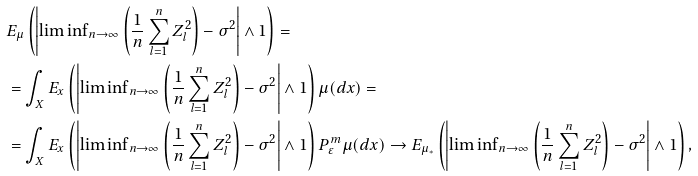Convert formula to latex. <formula><loc_0><loc_0><loc_500><loc_500>& E _ { \mu } \left ( \left | { \lim \inf } _ { n \to \infty } \left ( \frac { 1 } { n } \sum _ { l = 1 } ^ { n } Z _ { l } ^ { 2 } \right ) - \sigma ^ { 2 } \right | \wedge 1 \right ) = \\ & = \int _ { X } E _ { x } \left ( \left | { \lim \inf } _ { n \to \infty } \left ( \frac { 1 } { n } \sum _ { l = 1 } ^ { n } Z _ { l } ^ { 2 } \right ) - \sigma ^ { 2 } \right | \wedge 1 \right ) \mu ( d x ) = \\ & = \int _ { X } E _ { x } \left ( \left | { \lim \inf } _ { n \to \infty } \left ( \frac { 1 } { n } \sum _ { l = 1 } ^ { n } Z _ { l } ^ { 2 } \right ) - \sigma ^ { 2 } \right | \wedge 1 \right ) P ^ { m } _ { \varepsilon } \mu ( d x ) \to E _ { \mu _ { * } } \left ( \left | { \lim \inf } _ { n \to \infty } \left ( \frac { 1 } { n } \sum _ { l = 1 } ^ { n } Z _ { l } ^ { 2 } \right ) - \sigma ^ { 2 } \right | \wedge 1 \right ) ,</formula> 